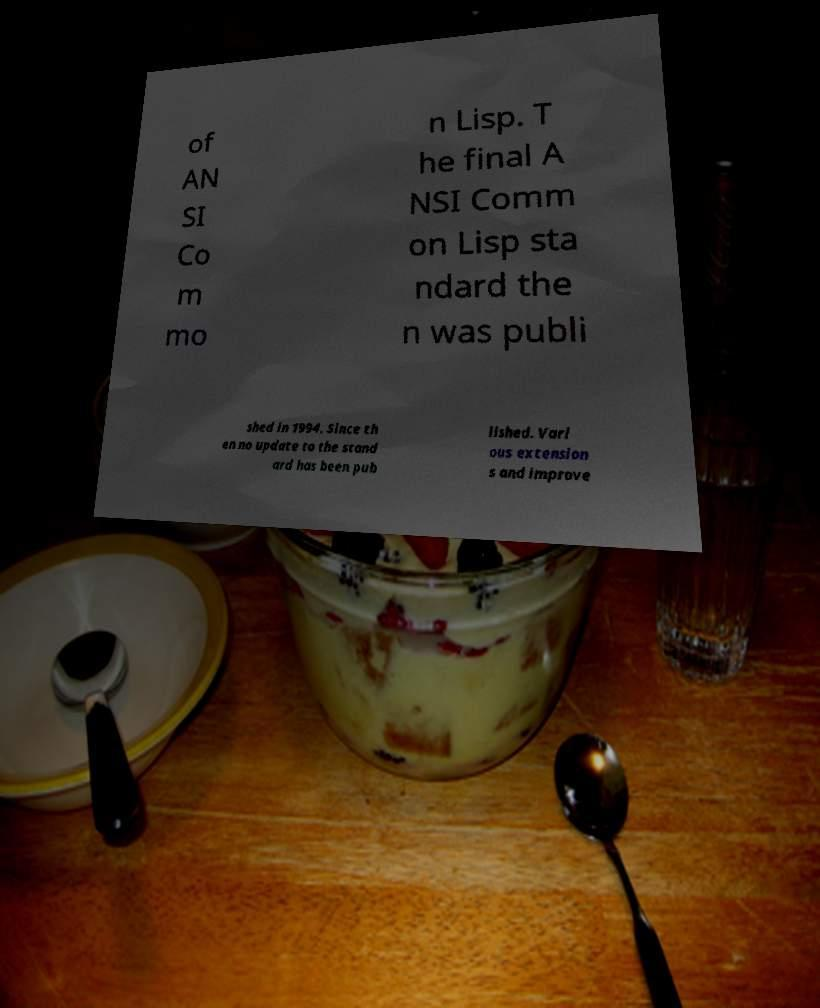For documentation purposes, I need the text within this image transcribed. Could you provide that? of AN SI Co m mo n Lisp. T he final A NSI Comm on Lisp sta ndard the n was publi shed in 1994. Since th en no update to the stand ard has been pub lished. Vari ous extension s and improve 